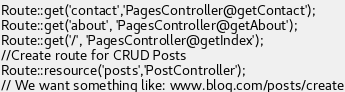<code> <loc_0><loc_0><loc_500><loc_500><_PHP_>Route::get('contact','PagesController@getContact');
Route::get('about', 'PagesController@getAbout');
Route::get('/', 'PagesController@getIndex');
//Create route for CRUD Posts
Route::resource('posts','PostController');
// We want something like: www.blog.com/posts/create
</code> 